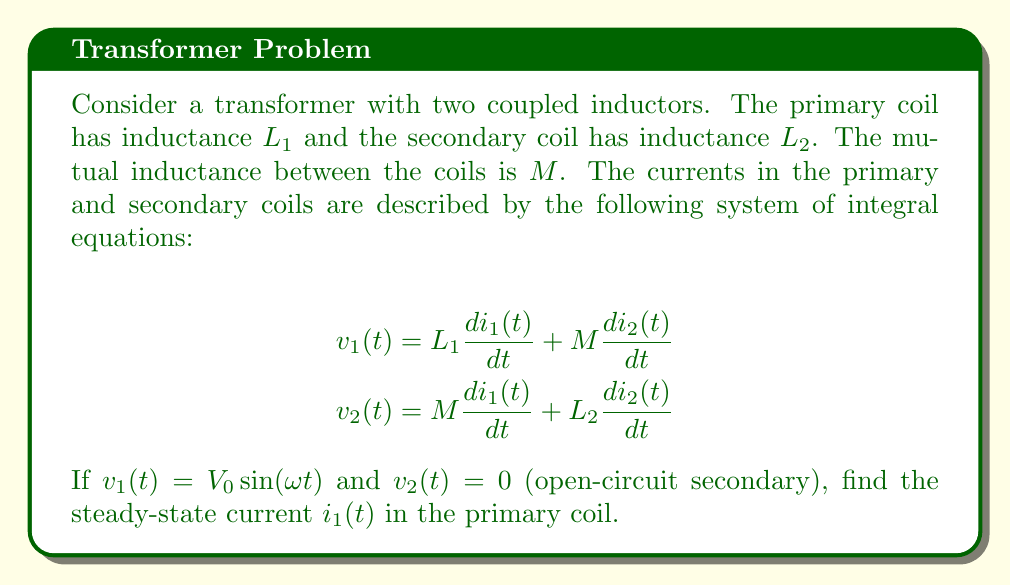Solve this math problem. To solve this problem, we'll follow these steps:

1) First, we need to recognize that in steady-state, the currents will have the same frequency as the input voltage. So, we can assume:

   $i_1(t) = I_1 \sin(\omega t + \phi_1)$
   $i_2(t) = I_2 \sin(\omega t + \phi_2)$

2) Since $v_2(t) = 0$, we can use the second equation to relate $i_1(t)$ and $i_2(t)$:

   $0 = M \frac{di_1(t)}{dt} + L_2 \frac{di_2(t)}{dt}$

3) Differentiating our assumed current forms:

   $\frac{di_1(t)}{dt} = I_1 \omega \cos(\omega t + \phi_1)$
   $\frac{di_2(t)}{dt} = I_2 \omega \cos(\omega t + \phi_2)$

4) Substituting into the equation from step 2:

   $0 = M I_1 \omega \cos(\omega t + \phi_1) + L_2 I_2 \omega \cos(\omega t + \phi_2)$

5) For this to be true for all $t$, we must have $\phi_1 = \phi_2$ and:

   $M I_1 + L_2 I_2 = 0$

6) Now, let's use the first equation:

   $V_0 \sin(\omega t) = L_1 \frac{di_1(t)}{dt} + M \frac{di_2(t)}{dt}$

7) Substituting the derivatives:

   $V_0 \sin(\omega t) = L_1 I_1 \omega \cos(\omega t + \phi_1) + M I_2 \omega \cos(\omega t + \phi_1)$

8) For this to be true, we must have $\phi_1 = -\pi/2$, and:

   $V_0 = \omega (L_1 I_1 + M I_2)$

9) From step 5, we know that $I_2 = -\frac{M}{L_2} I_1$. Substituting this into the equation from step 8:

   $V_0 = \omega (L_1 I_1 - M \frac{M}{L_2} I_1) = \omega I_1 (L_1 - \frac{M^2}{L_2})$

10) Solving for $I_1$:

    $I_1 = \frac{V_0}{\omega (L_1 - \frac{M^2}{L_2})}$

11) Therefore, the steady-state current in the primary coil is:

    $i_1(t) = \frac{V_0}{\omega (L_1 - \frac{M^2}{L_2})} \sin(\omega t - \frac{\pi}{2})$
Answer: $i_1(t) = \frac{V_0}{\omega (L_1 - \frac{M^2}{L_2})} \sin(\omega t - \frac{\pi}{2})$ 